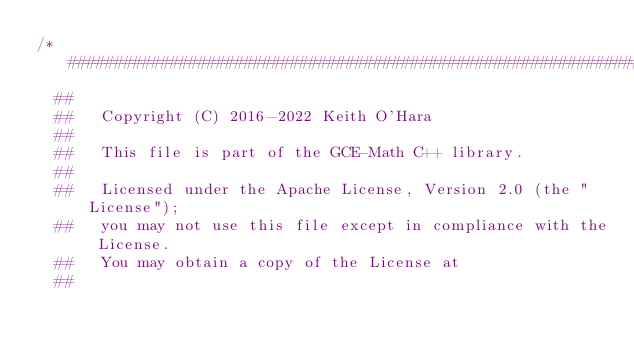Convert code to text. <code><loc_0><loc_0><loc_500><loc_500><_C++_>/*################################################################################
  ##
  ##   Copyright (C) 2016-2022 Keith O'Hara
  ##
  ##   This file is part of the GCE-Math C++ library.
  ##
  ##   Licensed under the Apache License, Version 2.0 (the "License");
  ##   you may not use this file except in compliance with the License.
  ##   You may obtain a copy of the License at
  ##</code> 